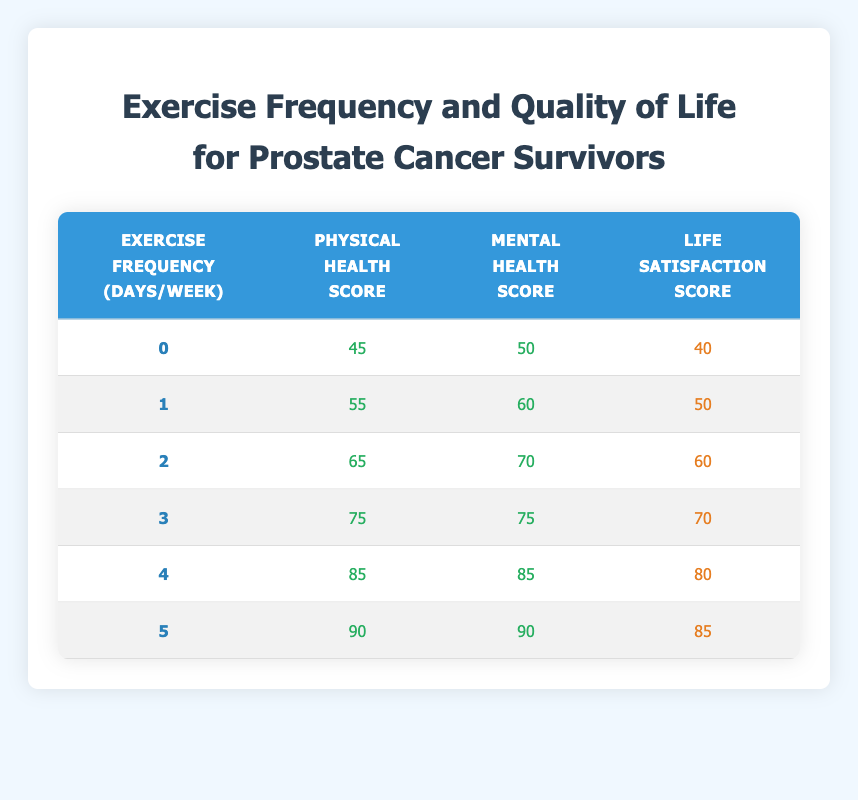What is the physical health score for those who exercise 3 days a week? Referring to the table, when the exercise frequency is 3 days a week, the corresponding physical health score is 75.
Answer: 75 What is the mental health score for those who exercise 0 days a week? Looking at the table, the mental health score for an exercise frequency of 0 days a week is 50.
Answer: 50 What is the average life satisfaction score for individuals who exercise 4 and 5 days a week? First, the life satisfaction scores for 4 and 5 days a week are 80 and 85, respectively. The total score is 80 + 85 = 165. There are 2 individuals, so the average is 165 / 2 = 82.5.
Answer: 82.5 Is the physical health score higher for individuals who exercise 5 days a week compared to those who exercise 1 day a week? The physical health score for those who exercise 5 days a week is 90, while for those who exercise 1 day a week it is 55. Since 90 is greater than 55, the statement is true.
Answer: Yes What is the difference between the mental health scores of individuals who exercise 2 days a week and those who exercise 4 days a week? The mental health score for those exercising 2 days a week is 70, while for those exercising 4 days a week it is 85. The difference is calculated as 85 - 70 = 15.
Answer: 15 How many total health improvement points (physical + mental + life satisfaction) do those who exercise 3 days a week have compared to those who exercise 1 day a week? For 3 days a week, the scores are 75 (physical) + 75 (mental) + 70 (life satisfaction) = 220. For 1 day a week, the scores are 55 + 60 + 50 = 165. The total improvement points are 220 - 165 = 55.
Answer: 55 What is the highest life satisfaction score recorded in the table? Upon examining the table, the highest life satisfaction score corresponds to those who exercise 5 days a week, which is 85.
Answer: 85 Is there a correlation between increased exercise frequency and improved physical health score? Based on the table, as the exercise frequency increases, the physical health score also consistently increases, indicating a positive correlation.
Answer: Yes What is the physical health score for individuals who do not exercise at all? According to the table, individuals who do not exercise at all have a physical health score of 45.
Answer: 45 